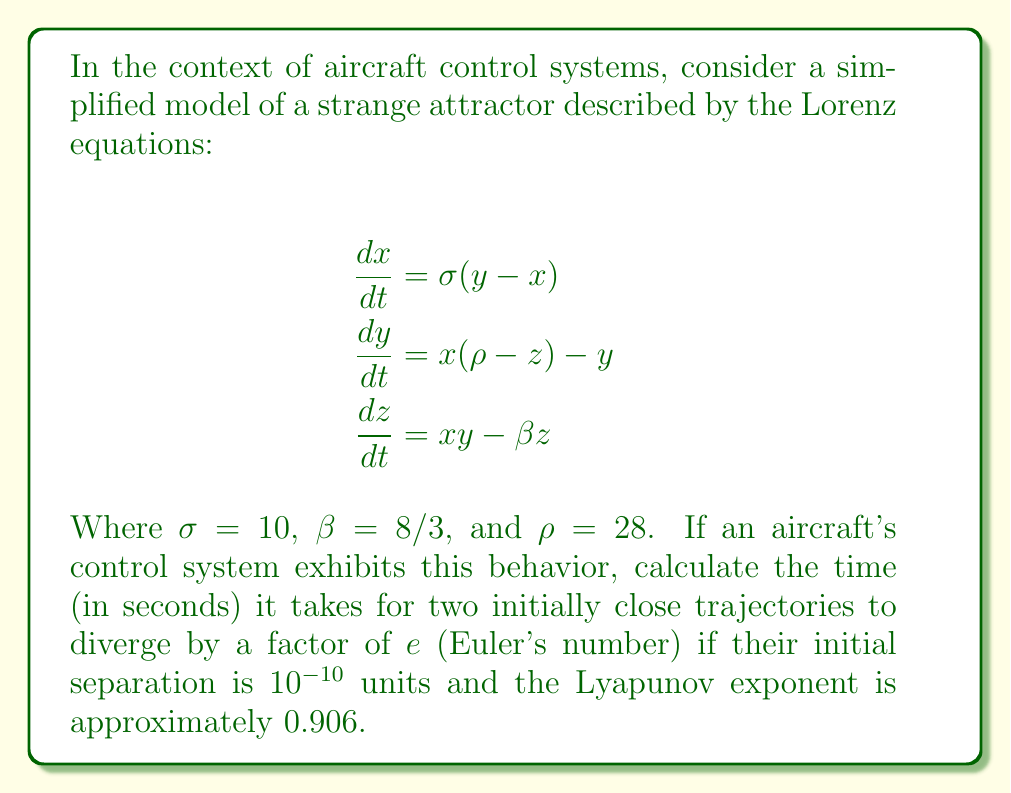What is the answer to this math problem? To solve this problem, we need to understand the concept of Lyapunov exponents and how they relate to the divergence of trajectories in a chaotic system. The Lyapunov exponent measures the rate of separation of infinitesimally close trajectories.

Given:
- Initial separation: $d_0 = 10^{-10}$ units
- Lyapunov exponent: $\lambda \approx 0.906$
- Divergence factor: $e$ (Euler's number)

Step 1: Recall the formula for the separation of trajectories over time:
$$d(t) = d_0 e^{\lambda t}$$

Step 2: We want to find the time $t$ when $d(t) = e \cdot d_0$. Substitute this into the equation:
$$e \cdot d_0 = d_0 e^{\lambda t}$$

Step 3: Simplify by canceling $d_0$ on both sides:
$$e = e^{\lambda t}$$

Step 4: Take the natural logarithm of both sides:
$$\ln(e) = \ln(e^{\lambda t})$$

Step 5: Simplify:
$$1 = \lambda t$$

Step 6: Solve for $t$:
$$t = \frac{1}{\lambda}$$

Step 7: Substitute the given Lyapunov exponent:
$$t = \frac{1}{0.906}$$

Step 8: Calculate the final result:
$$t \approx 1.1038 \text{ seconds}$$

This result shows that in a chaotic aircraft control system exhibiting the given Lorenz attractor behavior, two initially close trajectories would diverge by a factor of $e$ in approximately 1.1038 seconds, highlighting the system's sensitivity to initial conditions and the potential for rapid unpredictability in flight dynamics.
Answer: 1.1038 seconds 